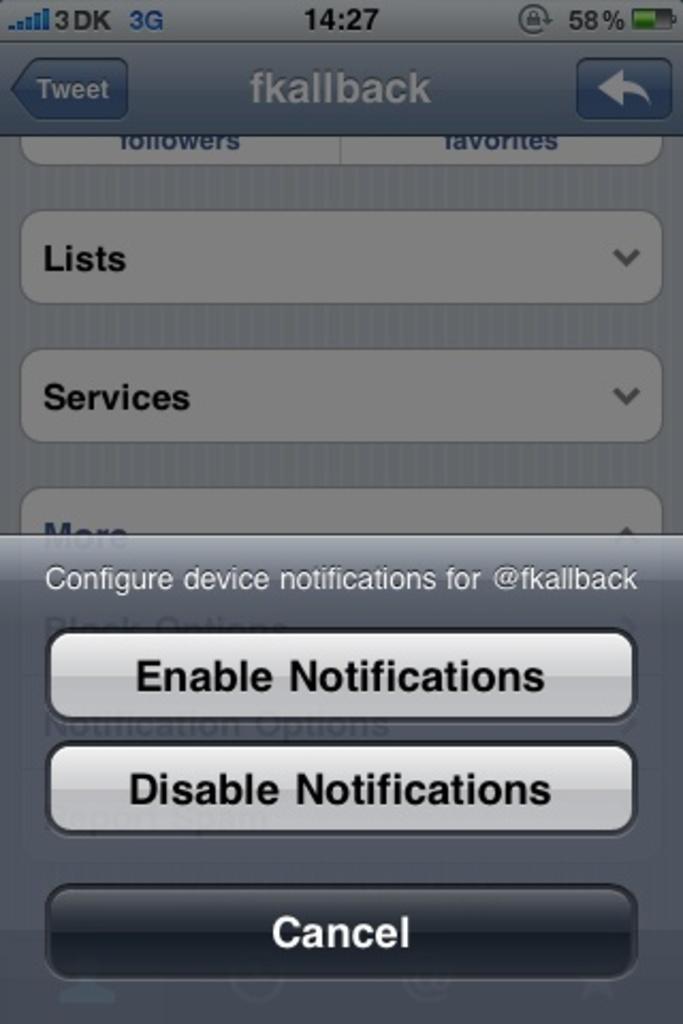How much batter life remains?
Provide a succinct answer. 58%. 